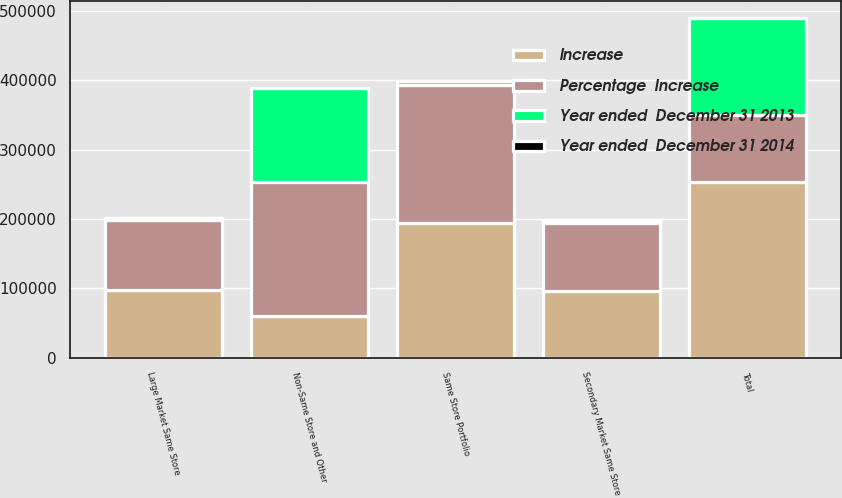Convert chart to OTSL. <chart><loc_0><loc_0><loc_500><loc_500><stacked_bar_chart><ecel><fcel>Large Market Same Store<fcel>Secondary Market Same Store<fcel>Same Store Portfolio<fcel>Non-Same Store and Other<fcel>Total<nl><fcel>Percentage  Increase<fcel>100892<fcel>98191<fcel>199083<fcel>194265<fcel>96141<nl><fcel>Increase<fcel>98190<fcel>96141<fcel>194331<fcel>59302<fcel>253633<nl><fcel>Year ended  December 31 2013<fcel>2702<fcel>2050<fcel>4752<fcel>134963<fcel>139715<nl><fcel>Year ended  December 31 2014<fcel>2.8<fcel>2.1<fcel>2.4<fcel>227.6<fcel>55.1<nl></chart> 